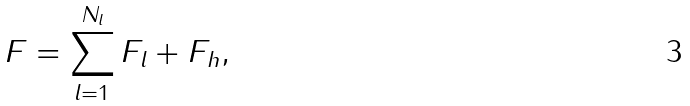Convert formula to latex. <formula><loc_0><loc_0><loc_500><loc_500>F = \sum _ { l = 1 } ^ { N _ { l } } F _ { l } + F _ { h } ,</formula> 